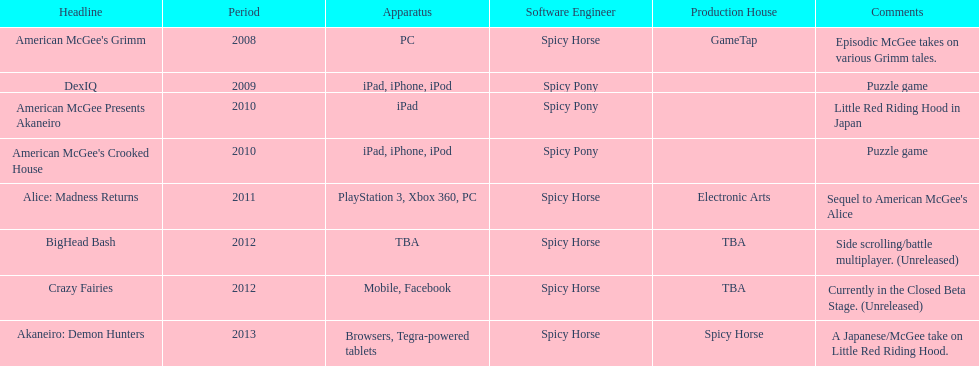What year had a total of 2 titles released? 2010. 